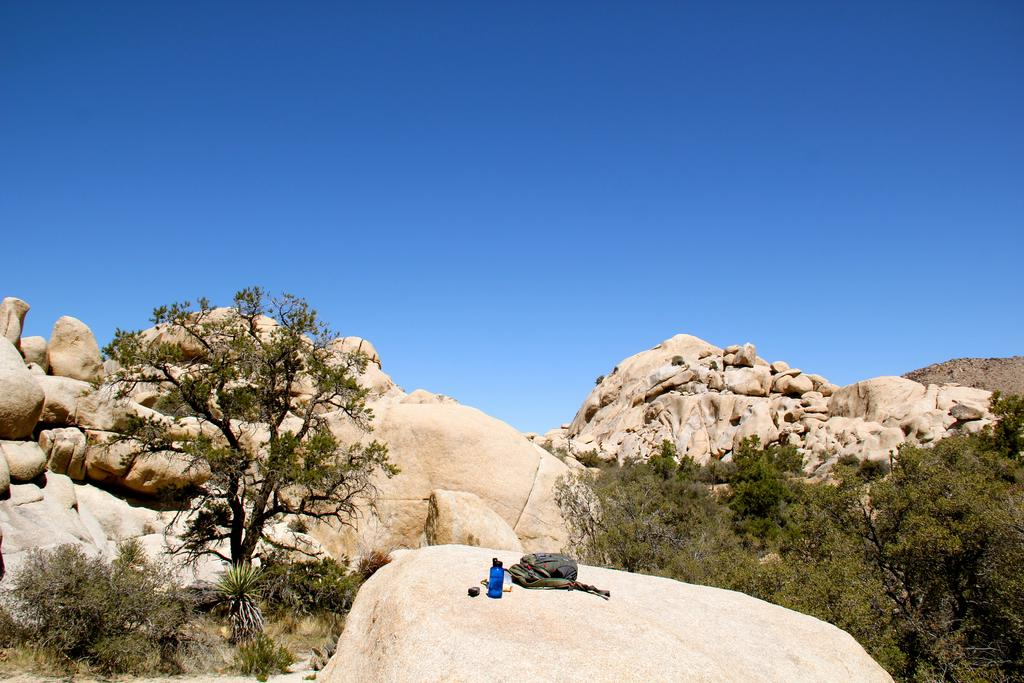What can be seen in the center of the image? The sky is visible in the center of the image. What type of natural features are present in the image? There are rocks, trees, and plants in the image. What man-made object can be seen in the image? There is a bag in the image. Can you describe the unspecified objects in the image? Unfortunately, the facts provided do not give any details about the unspecified objects in the image. How does the stranger interact with the wire in the image? There is no stranger or wire present in the image. 